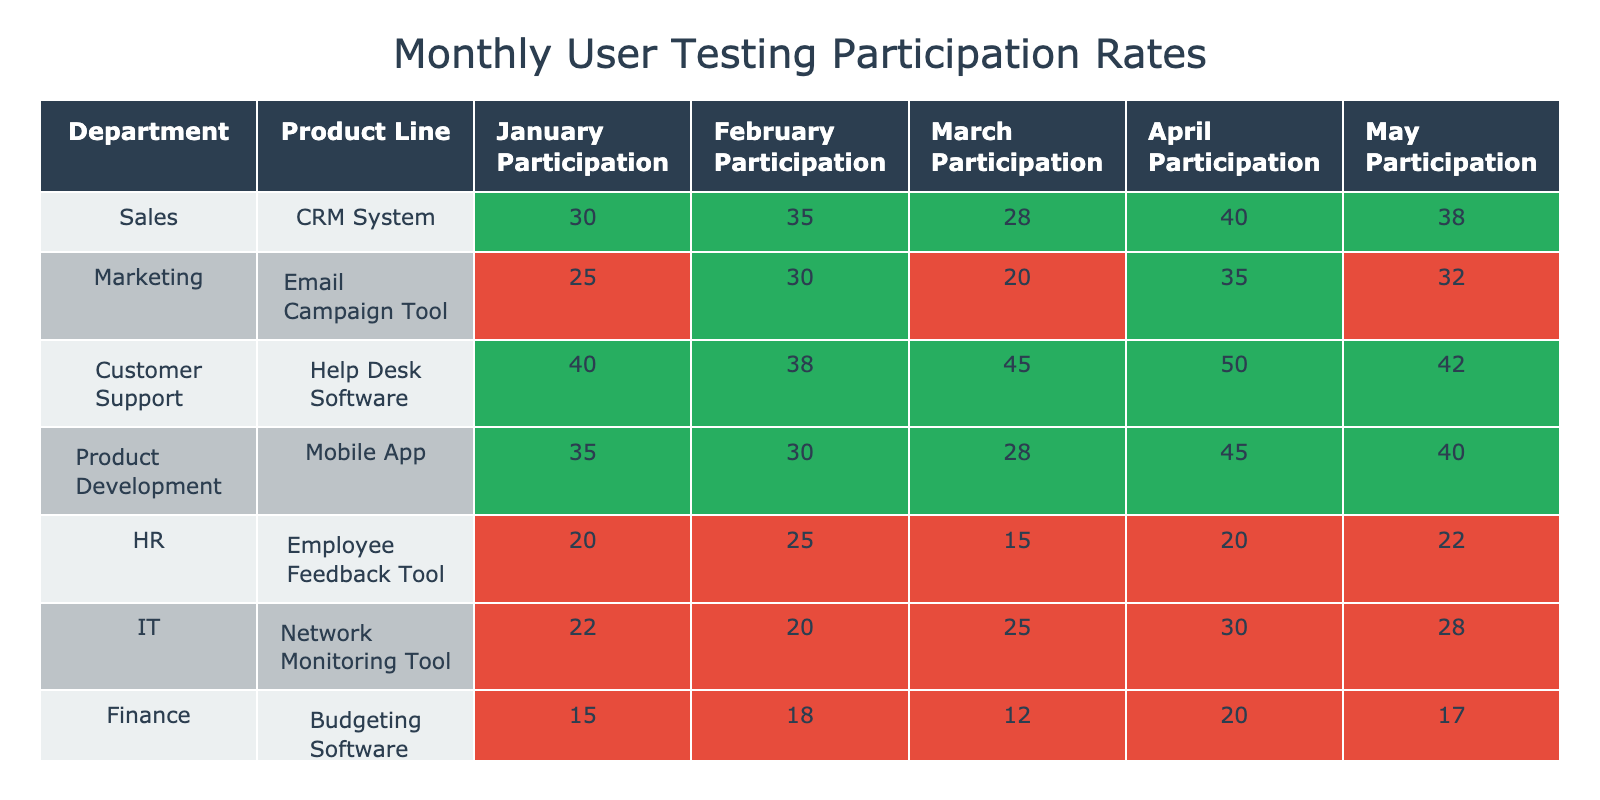What is the highest participation rate in April? Looking at the table for the month of April, the participation rates by department show that Customer Support has the highest rate at 50.
Answer: 50 Which department had the lowest participation rate in January? By examining the January participation rates, we find that Finance had the lowest rate at 15.
Answer: 15 What is the average participation rate for the HR department across all months? To find the average for HR: (20 + 25 + 15 + 20 + 22) = 102. Dividing by 5 gives an average of 102/5 = 20.4.
Answer: 20.4 Did the Marketing department's participation increase from January to February? Comparing the participation rates, Marketing had 25 in January and 30 in February, indicating an increase.
Answer: Yes What was the total participation rate across all months for the IT department? Adding the IT participation rates: 22 + 20 + 25 + 30 + 28 = 125 provides the total participation for IT.
Answer: 125 Which department showed a decrease in participation from February to March? Reviewing the participation from February to March, Marketing decreased from 30 to 20, so it shows a decrease.
Answer: Marketing What was the difference in participation between the highest and lowest department in May? In May, Customer Support had the highest participation at 42, and Finance had the lowest at 17. The difference is 42 - 17 = 25.
Answer: 25 Which product line had the most consistent participation rate based on visual inspection? Looking closely at the table, HR's rates are relatively close together, ranging from 15 to 25 with no extreme variations.
Answer: HR What is the median participation rate for the Sales department? The participation rates for Sales are 30, 35, 28, 40, and 38. Sorting these gives us 28, 30, 35, 38, 40. The median (middle value) is 35.
Answer: 35 